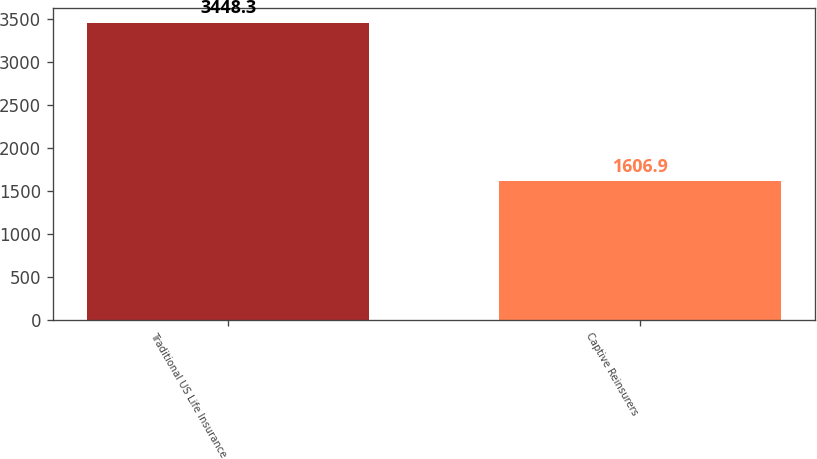Convert chart. <chart><loc_0><loc_0><loc_500><loc_500><bar_chart><fcel>Traditional US Life Insurance<fcel>Captive Reinsurers<nl><fcel>3448.3<fcel>1606.9<nl></chart> 